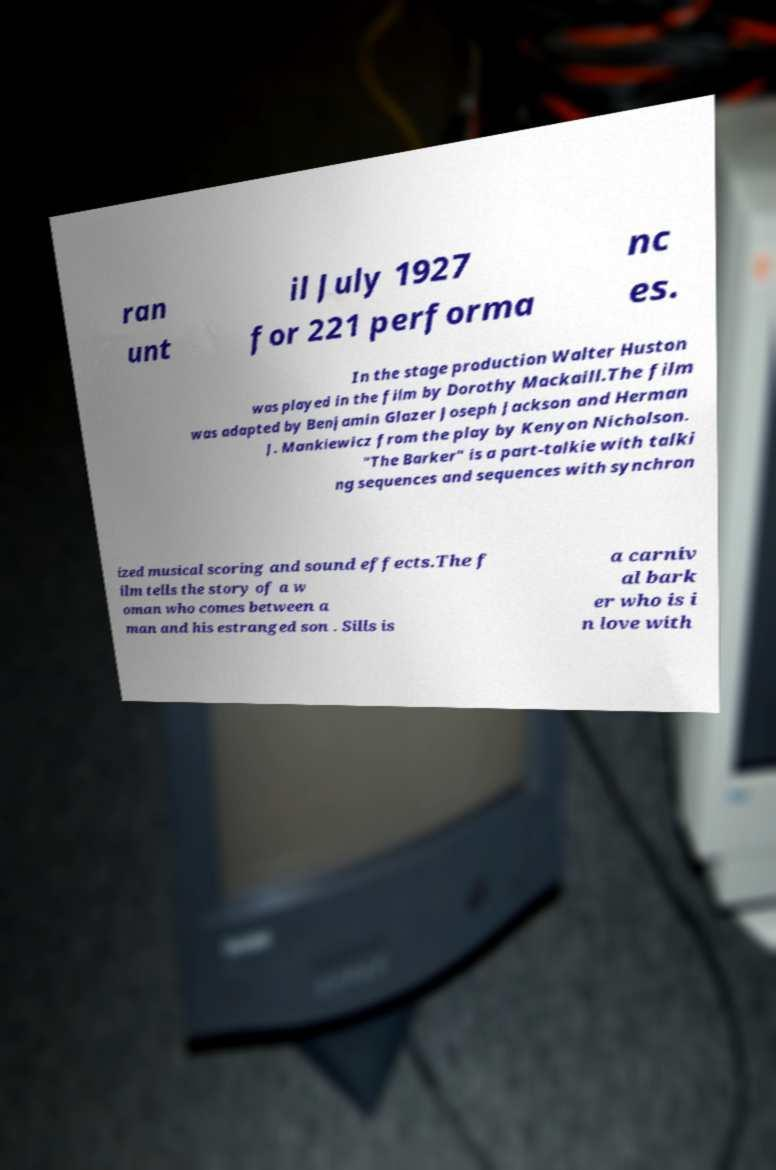Please read and relay the text visible in this image. What does it say? ran unt il July 1927 for 221 performa nc es. In the stage production Walter Huston was played in the film by Dorothy Mackaill.The film was adapted by Benjamin Glazer Joseph Jackson and Herman J. Mankiewicz from the play by Kenyon Nicholson. "The Barker" is a part-talkie with talki ng sequences and sequences with synchron ized musical scoring and sound effects.The f ilm tells the story of a w oman who comes between a man and his estranged son . Sills is a carniv al bark er who is i n love with 